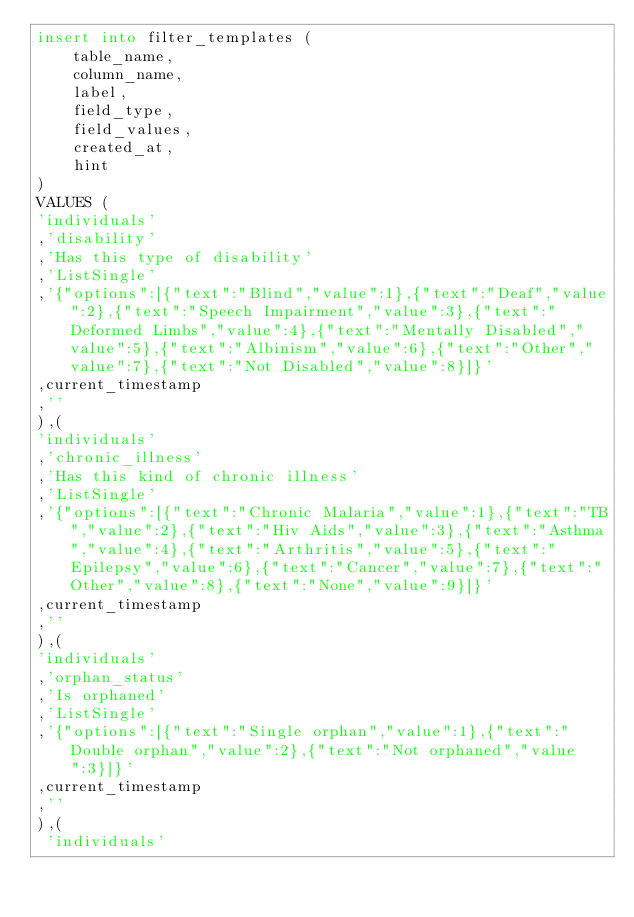Convert code to text. <code><loc_0><loc_0><loc_500><loc_500><_SQL_>insert into filter_templates (
    table_name,
    column_name,
    label,
    field_type,
    field_values,
    created_at,
    hint
)
VALUES (
'individuals'
,'disability'
,'Has this type of disability'
,'ListSingle'
,'{"options":[{"text":"Blind","value":1},{"text":"Deaf","value":2},{"text":"Speech Impairment","value":3},{"text":"Deformed Limbs","value":4},{"text":"Mentally Disabled","value":5},{"text":"Albinism","value":6},{"text":"Other","value":7},{"text":"Not Disabled","value":8}]}'
,current_timestamp
,''
),(
'individuals'
,'chronic_illness'
,'Has this kind of chronic illness'
,'ListSingle'
,'{"options":[{"text":"Chronic Malaria","value":1},{"text":"TB","value":2},{"text":"Hiv Aids","value":3},{"text":"Asthma","value":4},{"text":"Arthritis","value":5},{"text":"Epilepsy","value":6},{"text":"Cancer","value":7},{"text":"Other","value":8},{"text":"None","value":9}]}'
,current_timestamp
,''
),(
'individuals'
,'orphan_status'
,'Is orphaned'
,'ListSingle'
,'{"options":[{"text":"Single orphan","value":1},{"text":"Double orphan","value":2},{"text":"Not orphaned","value":3}]}'
,current_timestamp
,''
),(
 'individuals'</code> 